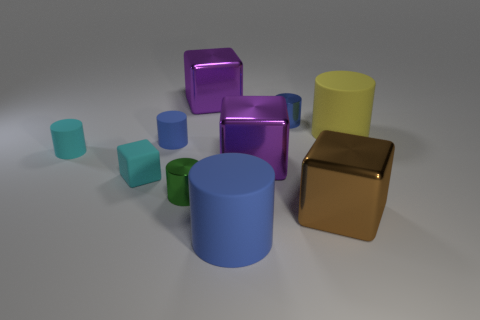How many tiny blue metal cylinders are there?
Keep it short and to the point. 1. What is the color of the other big cylinder that is the same material as the yellow cylinder?
Your answer should be compact. Blue. Is the number of large blue things greater than the number of large red metallic things?
Give a very brief answer. Yes. There is a rubber thing that is both in front of the small cyan cylinder and to the right of the tiny rubber block; how big is it?
Provide a short and direct response. Large. There is a tiny object that is the same color as the rubber cube; what is it made of?
Ensure brevity in your answer.  Rubber. Is the number of tiny cyan rubber cubes that are in front of the yellow cylinder the same as the number of big brown metallic blocks?
Provide a succinct answer. Yes. Is the size of the green thing the same as the cyan block?
Your answer should be very brief. Yes. There is a large metallic block that is behind the small cyan rubber cube and in front of the big yellow matte cylinder; what color is it?
Give a very brief answer. Purple. The purple thing that is on the right side of the big rubber object that is in front of the cyan block is made of what material?
Make the answer very short. Metal. There is a green shiny object that is the same shape as the small blue metal thing; what size is it?
Provide a short and direct response. Small. 